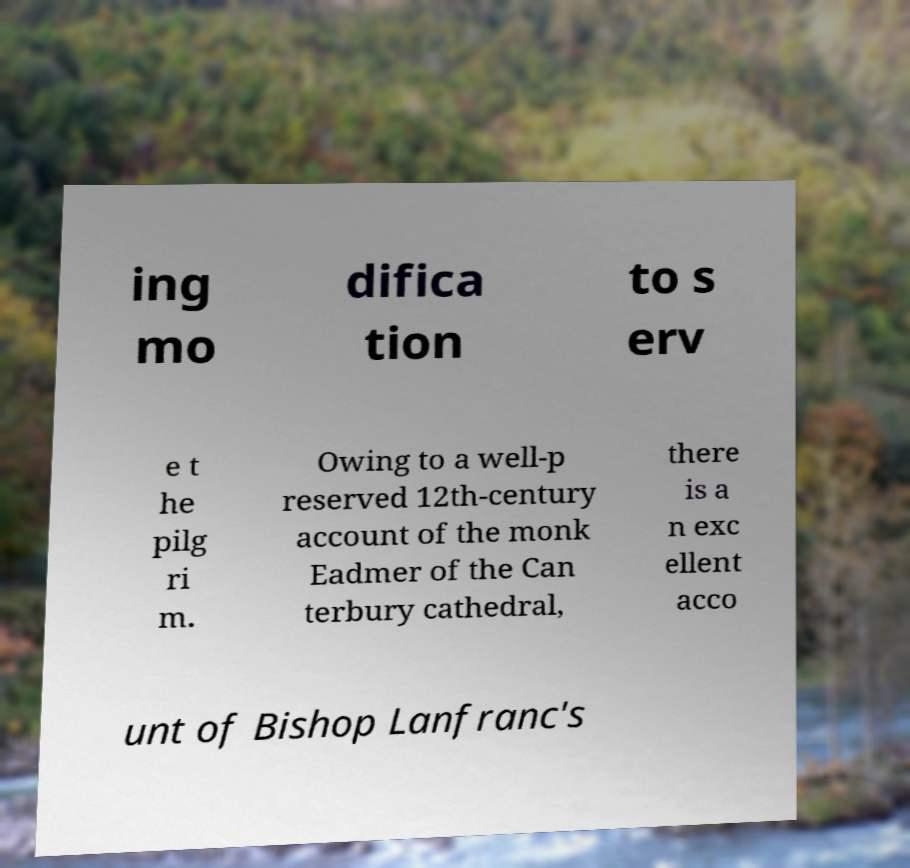Please read and relay the text visible in this image. What does it say? ing mo difica tion to s erv e t he pilg ri m. Owing to a well-p reserved 12th-century account of the monk Eadmer of the Can terbury cathedral, there is a n exc ellent acco unt of Bishop Lanfranc's 